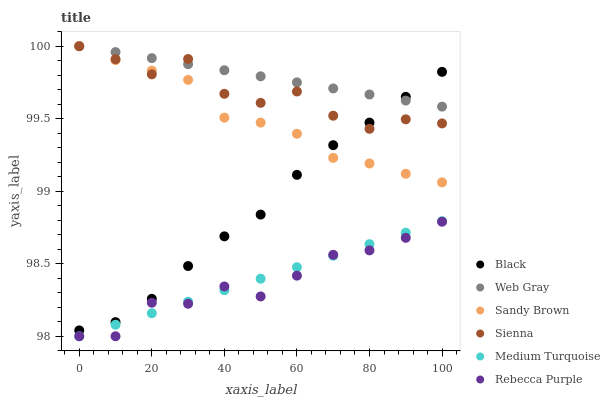Does Rebecca Purple have the minimum area under the curve?
Answer yes or no. Yes. Does Web Gray have the maximum area under the curve?
Answer yes or no. Yes. Does Sienna have the minimum area under the curve?
Answer yes or no. No. Does Sienna have the maximum area under the curve?
Answer yes or no. No. Is Web Gray the smoothest?
Answer yes or no. Yes. Is Sienna the roughest?
Answer yes or no. Yes. Is Black the smoothest?
Answer yes or no. No. Is Black the roughest?
Answer yes or no. No. Does Rebecca Purple have the lowest value?
Answer yes or no. Yes. Does Sienna have the lowest value?
Answer yes or no. No. Does Sandy Brown have the highest value?
Answer yes or no. Yes. Does Sienna have the highest value?
Answer yes or no. No. Is Rebecca Purple less than Sienna?
Answer yes or no. Yes. Is Sienna greater than Medium Turquoise?
Answer yes or no. Yes. Does Sienna intersect Sandy Brown?
Answer yes or no. Yes. Is Sienna less than Sandy Brown?
Answer yes or no. No. Is Sienna greater than Sandy Brown?
Answer yes or no. No. Does Rebecca Purple intersect Sienna?
Answer yes or no. No. 